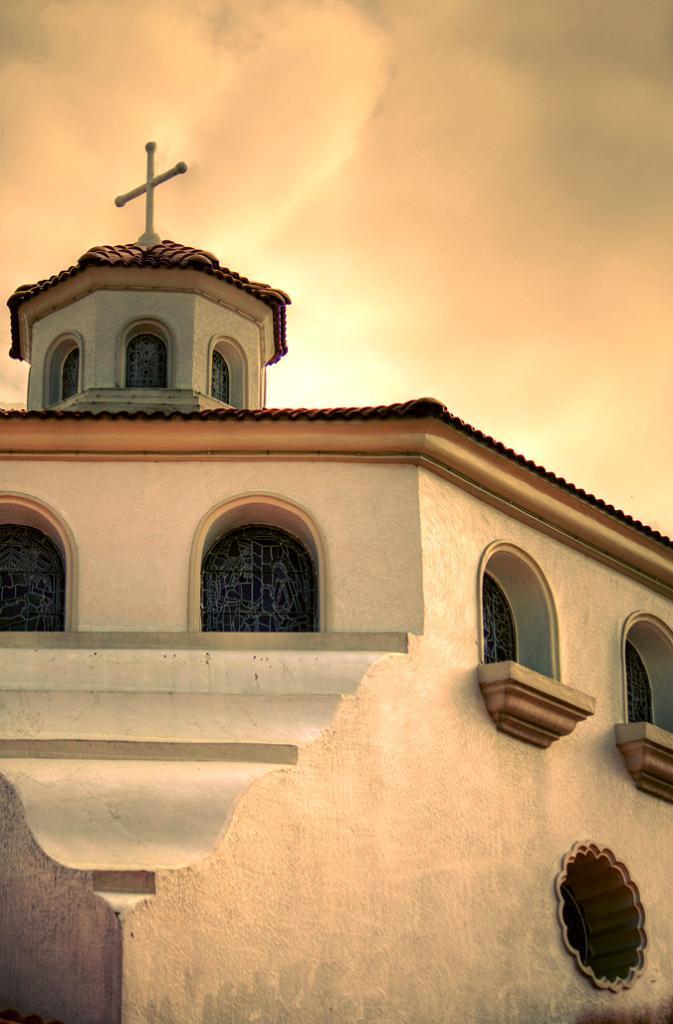In one or two sentences, can you explain what this image depicts? In the center of the image we can see the sky, windows, one building, cross and a wall. 